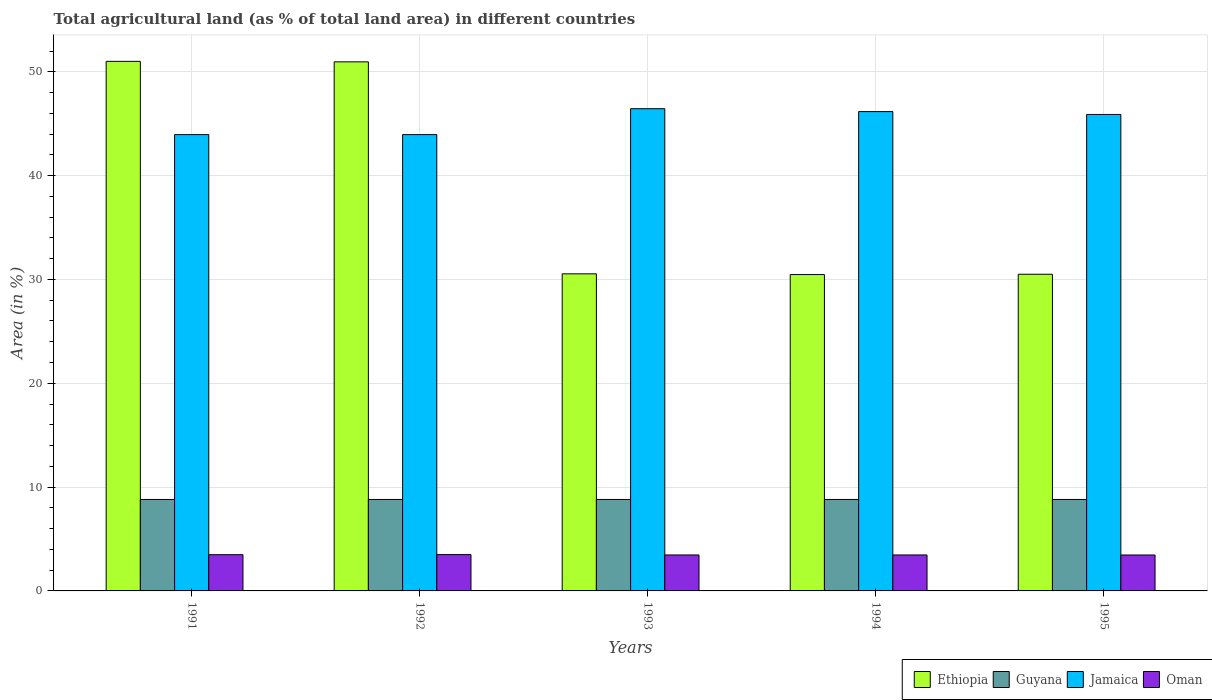How many different coloured bars are there?
Provide a succinct answer. 4. Are the number of bars per tick equal to the number of legend labels?
Provide a short and direct response. Yes. How many bars are there on the 2nd tick from the left?
Offer a terse response. 4. In how many cases, is the number of bars for a given year not equal to the number of legend labels?
Offer a very short reply. 0. What is the percentage of agricultural land in Jamaica in 1993?
Provide a short and direct response. 46.45. Across all years, what is the maximum percentage of agricultural land in Ethiopia?
Provide a short and direct response. 51.01. Across all years, what is the minimum percentage of agricultural land in Oman?
Your response must be concise. 3.46. In which year was the percentage of agricultural land in Oman minimum?
Your response must be concise. 1995. What is the total percentage of agricultural land in Jamaica in the graph?
Offer a terse response. 226.41. What is the difference between the percentage of agricultural land in Oman in 1992 and the percentage of agricultural land in Guyana in 1991?
Give a very brief answer. -5.31. What is the average percentage of agricultural land in Guyana per year?
Offer a very short reply. 8.81. In the year 1993, what is the difference between the percentage of agricultural land in Ethiopia and percentage of agricultural land in Jamaica?
Make the answer very short. -15.91. In how many years, is the percentage of agricultural land in Ethiopia greater than 32 %?
Provide a succinct answer. 2. What is the ratio of the percentage of agricultural land in Jamaica in 1991 to that in 1994?
Give a very brief answer. 0.95. Is the difference between the percentage of agricultural land in Ethiopia in 1993 and 1995 greater than the difference between the percentage of agricultural land in Jamaica in 1993 and 1995?
Provide a succinct answer. No. What is the difference between the highest and the second highest percentage of agricultural land in Jamaica?
Ensure brevity in your answer.  0.28. What is the difference between the highest and the lowest percentage of agricultural land in Ethiopia?
Give a very brief answer. 20.53. Is the sum of the percentage of agricultural land in Jamaica in 1992 and 1993 greater than the maximum percentage of agricultural land in Ethiopia across all years?
Your answer should be very brief. Yes. Is it the case that in every year, the sum of the percentage of agricultural land in Oman and percentage of agricultural land in Jamaica is greater than the sum of percentage of agricultural land in Ethiopia and percentage of agricultural land in Guyana?
Give a very brief answer. No. What does the 3rd bar from the left in 1993 represents?
Give a very brief answer. Jamaica. What does the 4th bar from the right in 1992 represents?
Offer a terse response. Ethiopia. How many bars are there?
Make the answer very short. 20. Are all the bars in the graph horizontal?
Offer a terse response. No. What is the difference between two consecutive major ticks on the Y-axis?
Your answer should be compact. 10. Does the graph contain any zero values?
Give a very brief answer. No. Does the graph contain grids?
Your answer should be very brief. Yes. Where does the legend appear in the graph?
Ensure brevity in your answer.  Bottom right. What is the title of the graph?
Provide a short and direct response. Total agricultural land (as % of total land area) in different countries. Does "Germany" appear as one of the legend labels in the graph?
Keep it short and to the point. No. What is the label or title of the Y-axis?
Make the answer very short. Area (in %). What is the Area (in %) in Ethiopia in 1991?
Keep it short and to the point. 51.01. What is the Area (in %) in Guyana in 1991?
Offer a terse response. 8.81. What is the Area (in %) of Jamaica in 1991?
Provide a short and direct response. 43.95. What is the Area (in %) in Oman in 1991?
Give a very brief answer. 3.49. What is the Area (in %) in Ethiopia in 1992?
Your answer should be very brief. 50.96. What is the Area (in %) of Guyana in 1992?
Ensure brevity in your answer.  8.81. What is the Area (in %) of Jamaica in 1992?
Give a very brief answer. 43.95. What is the Area (in %) of Oman in 1992?
Your answer should be compact. 3.5. What is the Area (in %) in Ethiopia in 1993?
Provide a succinct answer. 30.54. What is the Area (in %) in Guyana in 1993?
Provide a succinct answer. 8.81. What is the Area (in %) of Jamaica in 1993?
Give a very brief answer. 46.45. What is the Area (in %) in Oman in 1993?
Your answer should be very brief. 3.46. What is the Area (in %) in Ethiopia in 1994?
Your response must be concise. 30.47. What is the Area (in %) in Guyana in 1994?
Provide a short and direct response. 8.81. What is the Area (in %) in Jamaica in 1994?
Provide a succinct answer. 46.17. What is the Area (in %) of Oman in 1994?
Provide a short and direct response. 3.46. What is the Area (in %) of Ethiopia in 1995?
Provide a succinct answer. 30.5. What is the Area (in %) of Guyana in 1995?
Your response must be concise. 8.81. What is the Area (in %) of Jamaica in 1995?
Ensure brevity in your answer.  45.89. What is the Area (in %) of Oman in 1995?
Provide a short and direct response. 3.46. Across all years, what is the maximum Area (in %) in Ethiopia?
Your response must be concise. 51.01. Across all years, what is the maximum Area (in %) of Guyana?
Make the answer very short. 8.81. Across all years, what is the maximum Area (in %) of Jamaica?
Give a very brief answer. 46.45. Across all years, what is the maximum Area (in %) of Oman?
Provide a succinct answer. 3.5. Across all years, what is the minimum Area (in %) in Ethiopia?
Your answer should be compact. 30.47. Across all years, what is the minimum Area (in %) of Guyana?
Provide a short and direct response. 8.81. Across all years, what is the minimum Area (in %) in Jamaica?
Give a very brief answer. 43.95. Across all years, what is the minimum Area (in %) of Oman?
Your answer should be very brief. 3.46. What is the total Area (in %) in Ethiopia in the graph?
Your response must be concise. 193.48. What is the total Area (in %) in Guyana in the graph?
Give a very brief answer. 44.04. What is the total Area (in %) of Jamaica in the graph?
Make the answer very short. 226.41. What is the total Area (in %) of Oman in the graph?
Give a very brief answer. 17.38. What is the difference between the Area (in %) of Ethiopia in 1991 and that in 1992?
Ensure brevity in your answer.  0.05. What is the difference between the Area (in %) in Guyana in 1991 and that in 1992?
Provide a short and direct response. 0. What is the difference between the Area (in %) in Jamaica in 1991 and that in 1992?
Your response must be concise. 0. What is the difference between the Area (in %) in Oman in 1991 and that in 1992?
Keep it short and to the point. -0.01. What is the difference between the Area (in %) of Ethiopia in 1991 and that in 1993?
Provide a succinct answer. 20.47. What is the difference between the Area (in %) in Guyana in 1991 and that in 1993?
Provide a succinct answer. 0. What is the difference between the Area (in %) in Jamaica in 1991 and that in 1993?
Give a very brief answer. -2.49. What is the difference between the Area (in %) in Oman in 1991 and that in 1993?
Ensure brevity in your answer.  0.03. What is the difference between the Area (in %) of Ethiopia in 1991 and that in 1994?
Offer a terse response. 20.53. What is the difference between the Area (in %) in Guyana in 1991 and that in 1994?
Make the answer very short. 0. What is the difference between the Area (in %) of Jamaica in 1991 and that in 1994?
Give a very brief answer. -2.22. What is the difference between the Area (in %) of Oman in 1991 and that in 1994?
Offer a terse response. 0.03. What is the difference between the Area (in %) in Ethiopia in 1991 and that in 1995?
Provide a short and direct response. 20.51. What is the difference between the Area (in %) in Jamaica in 1991 and that in 1995?
Your answer should be very brief. -1.94. What is the difference between the Area (in %) in Oman in 1991 and that in 1995?
Your response must be concise. 0.03. What is the difference between the Area (in %) of Ethiopia in 1992 and that in 1993?
Give a very brief answer. 20.42. What is the difference between the Area (in %) of Guyana in 1992 and that in 1993?
Offer a terse response. 0. What is the difference between the Area (in %) in Jamaica in 1992 and that in 1993?
Offer a very short reply. -2.49. What is the difference between the Area (in %) of Oman in 1992 and that in 1993?
Offer a terse response. 0.04. What is the difference between the Area (in %) in Ethiopia in 1992 and that in 1994?
Provide a short and direct response. 20.49. What is the difference between the Area (in %) of Guyana in 1992 and that in 1994?
Offer a very short reply. 0. What is the difference between the Area (in %) of Jamaica in 1992 and that in 1994?
Provide a succinct answer. -2.22. What is the difference between the Area (in %) in Oman in 1992 and that in 1994?
Your answer should be compact. 0.04. What is the difference between the Area (in %) of Ethiopia in 1992 and that in 1995?
Your answer should be very brief. 20.46. What is the difference between the Area (in %) of Guyana in 1992 and that in 1995?
Provide a short and direct response. 0. What is the difference between the Area (in %) of Jamaica in 1992 and that in 1995?
Provide a succinct answer. -1.94. What is the difference between the Area (in %) in Oman in 1992 and that in 1995?
Offer a terse response. 0.04. What is the difference between the Area (in %) in Ethiopia in 1993 and that in 1994?
Provide a succinct answer. 0.07. What is the difference between the Area (in %) in Jamaica in 1993 and that in 1994?
Ensure brevity in your answer.  0.28. What is the difference between the Area (in %) in Oman in 1993 and that in 1994?
Give a very brief answer. 0. What is the difference between the Area (in %) of Guyana in 1993 and that in 1995?
Provide a succinct answer. 0. What is the difference between the Area (in %) of Jamaica in 1993 and that in 1995?
Give a very brief answer. 0.55. What is the difference between the Area (in %) of Oman in 1993 and that in 1995?
Your answer should be very brief. 0. What is the difference between the Area (in %) in Ethiopia in 1994 and that in 1995?
Your answer should be compact. -0.03. What is the difference between the Area (in %) of Jamaica in 1994 and that in 1995?
Your answer should be very brief. 0.28. What is the difference between the Area (in %) of Oman in 1994 and that in 1995?
Offer a very short reply. 0. What is the difference between the Area (in %) in Ethiopia in 1991 and the Area (in %) in Guyana in 1992?
Your answer should be very brief. 42.2. What is the difference between the Area (in %) of Ethiopia in 1991 and the Area (in %) of Jamaica in 1992?
Make the answer very short. 7.05. What is the difference between the Area (in %) of Ethiopia in 1991 and the Area (in %) of Oman in 1992?
Give a very brief answer. 47.51. What is the difference between the Area (in %) of Guyana in 1991 and the Area (in %) of Jamaica in 1992?
Offer a very short reply. -35.14. What is the difference between the Area (in %) in Guyana in 1991 and the Area (in %) in Oman in 1992?
Your answer should be very brief. 5.31. What is the difference between the Area (in %) of Jamaica in 1991 and the Area (in %) of Oman in 1992?
Your answer should be compact. 40.45. What is the difference between the Area (in %) in Ethiopia in 1991 and the Area (in %) in Guyana in 1993?
Your response must be concise. 42.2. What is the difference between the Area (in %) in Ethiopia in 1991 and the Area (in %) in Jamaica in 1993?
Offer a terse response. 4.56. What is the difference between the Area (in %) in Ethiopia in 1991 and the Area (in %) in Oman in 1993?
Your response must be concise. 47.54. What is the difference between the Area (in %) in Guyana in 1991 and the Area (in %) in Jamaica in 1993?
Your answer should be compact. -37.64. What is the difference between the Area (in %) in Guyana in 1991 and the Area (in %) in Oman in 1993?
Your response must be concise. 5.35. What is the difference between the Area (in %) of Jamaica in 1991 and the Area (in %) of Oman in 1993?
Offer a terse response. 40.49. What is the difference between the Area (in %) of Ethiopia in 1991 and the Area (in %) of Guyana in 1994?
Ensure brevity in your answer.  42.2. What is the difference between the Area (in %) in Ethiopia in 1991 and the Area (in %) in Jamaica in 1994?
Your answer should be very brief. 4.84. What is the difference between the Area (in %) of Ethiopia in 1991 and the Area (in %) of Oman in 1994?
Your answer should be compact. 47.54. What is the difference between the Area (in %) of Guyana in 1991 and the Area (in %) of Jamaica in 1994?
Give a very brief answer. -37.36. What is the difference between the Area (in %) of Guyana in 1991 and the Area (in %) of Oman in 1994?
Provide a succinct answer. 5.35. What is the difference between the Area (in %) of Jamaica in 1991 and the Area (in %) of Oman in 1994?
Keep it short and to the point. 40.49. What is the difference between the Area (in %) in Ethiopia in 1991 and the Area (in %) in Guyana in 1995?
Your answer should be compact. 42.2. What is the difference between the Area (in %) of Ethiopia in 1991 and the Area (in %) of Jamaica in 1995?
Give a very brief answer. 5.12. What is the difference between the Area (in %) of Ethiopia in 1991 and the Area (in %) of Oman in 1995?
Your answer should be compact. 47.55. What is the difference between the Area (in %) in Guyana in 1991 and the Area (in %) in Jamaica in 1995?
Provide a short and direct response. -37.08. What is the difference between the Area (in %) in Guyana in 1991 and the Area (in %) in Oman in 1995?
Ensure brevity in your answer.  5.35. What is the difference between the Area (in %) in Jamaica in 1991 and the Area (in %) in Oman in 1995?
Provide a short and direct response. 40.49. What is the difference between the Area (in %) of Ethiopia in 1992 and the Area (in %) of Guyana in 1993?
Your answer should be very brief. 42.15. What is the difference between the Area (in %) of Ethiopia in 1992 and the Area (in %) of Jamaica in 1993?
Your answer should be compact. 4.51. What is the difference between the Area (in %) of Ethiopia in 1992 and the Area (in %) of Oman in 1993?
Offer a very short reply. 47.49. What is the difference between the Area (in %) of Guyana in 1992 and the Area (in %) of Jamaica in 1993?
Your answer should be very brief. -37.64. What is the difference between the Area (in %) of Guyana in 1992 and the Area (in %) of Oman in 1993?
Keep it short and to the point. 5.35. What is the difference between the Area (in %) in Jamaica in 1992 and the Area (in %) in Oman in 1993?
Provide a short and direct response. 40.49. What is the difference between the Area (in %) in Ethiopia in 1992 and the Area (in %) in Guyana in 1994?
Offer a terse response. 42.15. What is the difference between the Area (in %) of Ethiopia in 1992 and the Area (in %) of Jamaica in 1994?
Give a very brief answer. 4.79. What is the difference between the Area (in %) of Ethiopia in 1992 and the Area (in %) of Oman in 1994?
Provide a short and direct response. 47.49. What is the difference between the Area (in %) in Guyana in 1992 and the Area (in %) in Jamaica in 1994?
Your answer should be compact. -37.36. What is the difference between the Area (in %) in Guyana in 1992 and the Area (in %) in Oman in 1994?
Offer a terse response. 5.35. What is the difference between the Area (in %) of Jamaica in 1992 and the Area (in %) of Oman in 1994?
Offer a terse response. 40.49. What is the difference between the Area (in %) in Ethiopia in 1992 and the Area (in %) in Guyana in 1995?
Your answer should be very brief. 42.15. What is the difference between the Area (in %) in Ethiopia in 1992 and the Area (in %) in Jamaica in 1995?
Give a very brief answer. 5.07. What is the difference between the Area (in %) in Ethiopia in 1992 and the Area (in %) in Oman in 1995?
Your response must be concise. 47.5. What is the difference between the Area (in %) of Guyana in 1992 and the Area (in %) of Jamaica in 1995?
Your response must be concise. -37.08. What is the difference between the Area (in %) of Guyana in 1992 and the Area (in %) of Oman in 1995?
Make the answer very short. 5.35. What is the difference between the Area (in %) of Jamaica in 1992 and the Area (in %) of Oman in 1995?
Offer a very short reply. 40.49. What is the difference between the Area (in %) in Ethiopia in 1993 and the Area (in %) in Guyana in 1994?
Ensure brevity in your answer.  21.73. What is the difference between the Area (in %) in Ethiopia in 1993 and the Area (in %) in Jamaica in 1994?
Keep it short and to the point. -15.63. What is the difference between the Area (in %) in Ethiopia in 1993 and the Area (in %) in Oman in 1994?
Keep it short and to the point. 27.08. What is the difference between the Area (in %) of Guyana in 1993 and the Area (in %) of Jamaica in 1994?
Your response must be concise. -37.36. What is the difference between the Area (in %) of Guyana in 1993 and the Area (in %) of Oman in 1994?
Keep it short and to the point. 5.35. What is the difference between the Area (in %) of Jamaica in 1993 and the Area (in %) of Oman in 1994?
Provide a succinct answer. 42.98. What is the difference between the Area (in %) in Ethiopia in 1993 and the Area (in %) in Guyana in 1995?
Your answer should be very brief. 21.73. What is the difference between the Area (in %) in Ethiopia in 1993 and the Area (in %) in Jamaica in 1995?
Ensure brevity in your answer.  -15.35. What is the difference between the Area (in %) in Ethiopia in 1993 and the Area (in %) in Oman in 1995?
Make the answer very short. 27.08. What is the difference between the Area (in %) in Guyana in 1993 and the Area (in %) in Jamaica in 1995?
Offer a very short reply. -37.08. What is the difference between the Area (in %) in Guyana in 1993 and the Area (in %) in Oman in 1995?
Offer a very short reply. 5.35. What is the difference between the Area (in %) of Jamaica in 1993 and the Area (in %) of Oman in 1995?
Ensure brevity in your answer.  42.98. What is the difference between the Area (in %) of Ethiopia in 1994 and the Area (in %) of Guyana in 1995?
Your answer should be very brief. 21.66. What is the difference between the Area (in %) of Ethiopia in 1994 and the Area (in %) of Jamaica in 1995?
Offer a terse response. -15.42. What is the difference between the Area (in %) of Ethiopia in 1994 and the Area (in %) of Oman in 1995?
Give a very brief answer. 27.01. What is the difference between the Area (in %) of Guyana in 1994 and the Area (in %) of Jamaica in 1995?
Give a very brief answer. -37.08. What is the difference between the Area (in %) in Guyana in 1994 and the Area (in %) in Oman in 1995?
Offer a very short reply. 5.35. What is the difference between the Area (in %) of Jamaica in 1994 and the Area (in %) of Oman in 1995?
Ensure brevity in your answer.  42.71. What is the average Area (in %) of Ethiopia per year?
Your answer should be compact. 38.7. What is the average Area (in %) in Guyana per year?
Ensure brevity in your answer.  8.81. What is the average Area (in %) of Jamaica per year?
Offer a very short reply. 45.28. What is the average Area (in %) in Oman per year?
Your answer should be compact. 3.48. In the year 1991, what is the difference between the Area (in %) in Ethiopia and Area (in %) in Guyana?
Offer a very short reply. 42.2. In the year 1991, what is the difference between the Area (in %) in Ethiopia and Area (in %) in Jamaica?
Give a very brief answer. 7.05. In the year 1991, what is the difference between the Area (in %) of Ethiopia and Area (in %) of Oman?
Ensure brevity in your answer.  47.52. In the year 1991, what is the difference between the Area (in %) in Guyana and Area (in %) in Jamaica?
Keep it short and to the point. -35.14. In the year 1991, what is the difference between the Area (in %) of Guyana and Area (in %) of Oman?
Your response must be concise. 5.32. In the year 1991, what is the difference between the Area (in %) in Jamaica and Area (in %) in Oman?
Ensure brevity in your answer.  40.46. In the year 1992, what is the difference between the Area (in %) in Ethiopia and Area (in %) in Guyana?
Provide a succinct answer. 42.15. In the year 1992, what is the difference between the Area (in %) of Ethiopia and Area (in %) of Jamaica?
Give a very brief answer. 7.01. In the year 1992, what is the difference between the Area (in %) in Ethiopia and Area (in %) in Oman?
Your answer should be very brief. 47.46. In the year 1992, what is the difference between the Area (in %) of Guyana and Area (in %) of Jamaica?
Provide a succinct answer. -35.14. In the year 1992, what is the difference between the Area (in %) of Guyana and Area (in %) of Oman?
Provide a succinct answer. 5.31. In the year 1992, what is the difference between the Area (in %) in Jamaica and Area (in %) in Oman?
Your answer should be very brief. 40.45. In the year 1993, what is the difference between the Area (in %) in Ethiopia and Area (in %) in Guyana?
Your response must be concise. 21.73. In the year 1993, what is the difference between the Area (in %) in Ethiopia and Area (in %) in Jamaica?
Your answer should be compact. -15.91. In the year 1993, what is the difference between the Area (in %) in Ethiopia and Area (in %) in Oman?
Ensure brevity in your answer.  27.08. In the year 1993, what is the difference between the Area (in %) in Guyana and Area (in %) in Jamaica?
Provide a succinct answer. -37.64. In the year 1993, what is the difference between the Area (in %) in Guyana and Area (in %) in Oman?
Your response must be concise. 5.35. In the year 1993, what is the difference between the Area (in %) in Jamaica and Area (in %) in Oman?
Your answer should be compact. 42.98. In the year 1994, what is the difference between the Area (in %) of Ethiopia and Area (in %) of Guyana?
Your answer should be very brief. 21.66. In the year 1994, what is the difference between the Area (in %) of Ethiopia and Area (in %) of Jamaica?
Provide a succinct answer. -15.7. In the year 1994, what is the difference between the Area (in %) of Ethiopia and Area (in %) of Oman?
Make the answer very short. 27.01. In the year 1994, what is the difference between the Area (in %) in Guyana and Area (in %) in Jamaica?
Provide a succinct answer. -37.36. In the year 1994, what is the difference between the Area (in %) in Guyana and Area (in %) in Oman?
Offer a terse response. 5.35. In the year 1994, what is the difference between the Area (in %) of Jamaica and Area (in %) of Oman?
Give a very brief answer. 42.7. In the year 1995, what is the difference between the Area (in %) in Ethiopia and Area (in %) in Guyana?
Your answer should be very brief. 21.69. In the year 1995, what is the difference between the Area (in %) of Ethiopia and Area (in %) of Jamaica?
Keep it short and to the point. -15.39. In the year 1995, what is the difference between the Area (in %) in Ethiopia and Area (in %) in Oman?
Give a very brief answer. 27.04. In the year 1995, what is the difference between the Area (in %) of Guyana and Area (in %) of Jamaica?
Provide a succinct answer. -37.08. In the year 1995, what is the difference between the Area (in %) in Guyana and Area (in %) in Oman?
Make the answer very short. 5.35. In the year 1995, what is the difference between the Area (in %) in Jamaica and Area (in %) in Oman?
Your response must be concise. 42.43. What is the ratio of the Area (in %) in Jamaica in 1991 to that in 1992?
Provide a short and direct response. 1. What is the ratio of the Area (in %) of Ethiopia in 1991 to that in 1993?
Offer a very short reply. 1.67. What is the ratio of the Area (in %) of Guyana in 1991 to that in 1993?
Your answer should be very brief. 1. What is the ratio of the Area (in %) in Jamaica in 1991 to that in 1993?
Offer a terse response. 0.95. What is the ratio of the Area (in %) of Oman in 1991 to that in 1993?
Your response must be concise. 1.01. What is the ratio of the Area (in %) of Ethiopia in 1991 to that in 1994?
Provide a short and direct response. 1.67. What is the ratio of the Area (in %) of Oman in 1991 to that in 1994?
Give a very brief answer. 1.01. What is the ratio of the Area (in %) in Ethiopia in 1991 to that in 1995?
Provide a short and direct response. 1.67. What is the ratio of the Area (in %) of Jamaica in 1991 to that in 1995?
Your answer should be very brief. 0.96. What is the ratio of the Area (in %) in Oman in 1991 to that in 1995?
Offer a terse response. 1.01. What is the ratio of the Area (in %) of Ethiopia in 1992 to that in 1993?
Give a very brief answer. 1.67. What is the ratio of the Area (in %) in Jamaica in 1992 to that in 1993?
Your response must be concise. 0.95. What is the ratio of the Area (in %) in Oman in 1992 to that in 1993?
Your answer should be compact. 1.01. What is the ratio of the Area (in %) of Ethiopia in 1992 to that in 1994?
Your answer should be very brief. 1.67. What is the ratio of the Area (in %) in Guyana in 1992 to that in 1994?
Your answer should be compact. 1. What is the ratio of the Area (in %) of Oman in 1992 to that in 1994?
Make the answer very short. 1.01. What is the ratio of the Area (in %) of Ethiopia in 1992 to that in 1995?
Keep it short and to the point. 1.67. What is the ratio of the Area (in %) of Jamaica in 1992 to that in 1995?
Keep it short and to the point. 0.96. What is the ratio of the Area (in %) in Oman in 1992 to that in 1995?
Your response must be concise. 1.01. What is the ratio of the Area (in %) of Ethiopia in 1993 to that in 1994?
Ensure brevity in your answer.  1. What is the ratio of the Area (in %) of Guyana in 1993 to that in 1994?
Give a very brief answer. 1. What is the ratio of the Area (in %) of Oman in 1993 to that in 1994?
Your answer should be compact. 1. What is the ratio of the Area (in %) in Ethiopia in 1993 to that in 1995?
Your answer should be compact. 1. What is the ratio of the Area (in %) of Guyana in 1993 to that in 1995?
Ensure brevity in your answer.  1. What is the ratio of the Area (in %) in Jamaica in 1993 to that in 1995?
Your response must be concise. 1.01. What is the ratio of the Area (in %) in Ethiopia in 1994 to that in 1995?
Make the answer very short. 1. What is the ratio of the Area (in %) in Guyana in 1994 to that in 1995?
Give a very brief answer. 1. What is the ratio of the Area (in %) in Jamaica in 1994 to that in 1995?
Your answer should be very brief. 1.01. What is the ratio of the Area (in %) in Oman in 1994 to that in 1995?
Offer a terse response. 1. What is the difference between the highest and the second highest Area (in %) of Ethiopia?
Make the answer very short. 0.05. What is the difference between the highest and the second highest Area (in %) of Jamaica?
Ensure brevity in your answer.  0.28. What is the difference between the highest and the second highest Area (in %) in Oman?
Make the answer very short. 0.01. What is the difference between the highest and the lowest Area (in %) of Ethiopia?
Keep it short and to the point. 20.53. What is the difference between the highest and the lowest Area (in %) in Guyana?
Your answer should be compact. 0. What is the difference between the highest and the lowest Area (in %) of Jamaica?
Offer a very short reply. 2.49. What is the difference between the highest and the lowest Area (in %) in Oman?
Make the answer very short. 0.04. 